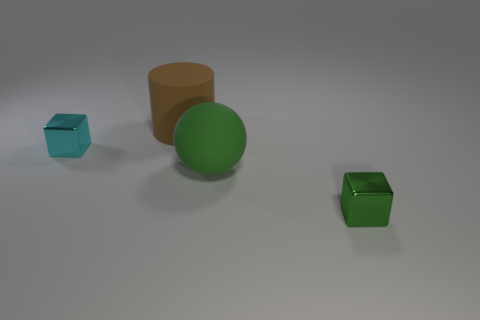What colors are the objects in the scene? The objects consist of a variety of colors: there is one orange cylinder, one green sphere, one cyan cube, and one green cube. 